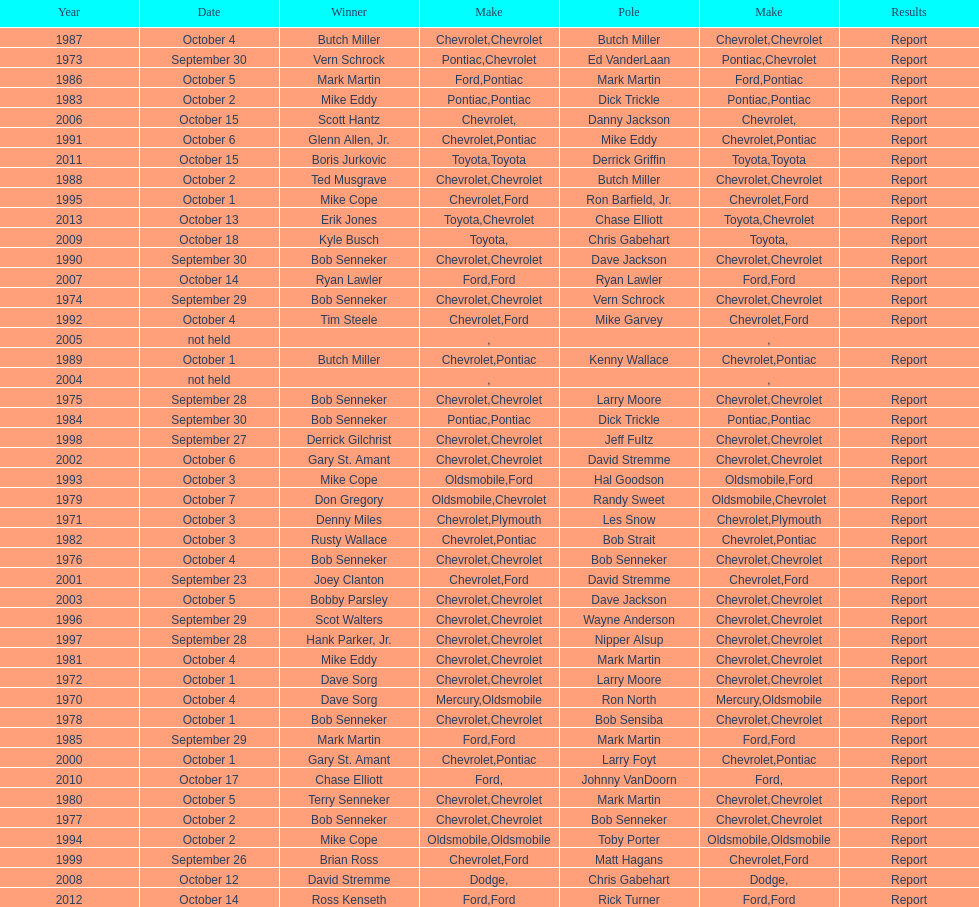Who on the list has the highest number of consecutive wins? Bob Senneker. Would you mind parsing the complete table? {'header': ['Year', 'Date', 'Winner', 'Make', 'Pole', 'Make', 'Results'], 'rows': [['1987', 'October 4', 'Butch Miller', 'Chevrolet', 'Butch Miller', 'Chevrolet', 'Report'], ['1973', 'September 30', 'Vern Schrock', 'Pontiac', 'Ed VanderLaan', 'Chevrolet', 'Report'], ['1986', 'October 5', 'Mark Martin', 'Ford', 'Mark Martin', 'Pontiac', 'Report'], ['1983', 'October 2', 'Mike Eddy', 'Pontiac', 'Dick Trickle', 'Pontiac', 'Report'], ['2006', 'October 15', 'Scott Hantz', 'Chevrolet', 'Danny Jackson', '', 'Report'], ['1991', 'October 6', 'Glenn Allen, Jr.', 'Chevrolet', 'Mike Eddy', 'Pontiac', 'Report'], ['2011', 'October 15', 'Boris Jurkovic', 'Toyota', 'Derrick Griffin', 'Toyota', 'Report'], ['1988', 'October 2', 'Ted Musgrave', 'Chevrolet', 'Butch Miller', 'Chevrolet', 'Report'], ['1995', 'October 1', 'Mike Cope', 'Chevrolet', 'Ron Barfield, Jr.', 'Ford', 'Report'], ['2013', 'October 13', 'Erik Jones', 'Toyota', 'Chase Elliott', 'Chevrolet', 'Report'], ['2009', 'October 18', 'Kyle Busch', 'Toyota', 'Chris Gabehart', '', 'Report'], ['1990', 'September 30', 'Bob Senneker', 'Chevrolet', 'Dave Jackson', 'Chevrolet', 'Report'], ['2007', 'October 14', 'Ryan Lawler', 'Ford', 'Ryan Lawler', 'Ford', 'Report'], ['1974', 'September 29', 'Bob Senneker', 'Chevrolet', 'Vern Schrock', 'Chevrolet', 'Report'], ['1992', 'October 4', 'Tim Steele', 'Chevrolet', 'Mike Garvey', 'Ford', 'Report'], ['2005', 'not held', '', '', '', '', ''], ['1989', 'October 1', 'Butch Miller', 'Chevrolet', 'Kenny Wallace', 'Pontiac', 'Report'], ['2004', 'not held', '', '', '', '', ''], ['1975', 'September 28', 'Bob Senneker', 'Chevrolet', 'Larry Moore', 'Chevrolet', 'Report'], ['1984', 'September 30', 'Bob Senneker', 'Pontiac', 'Dick Trickle', 'Pontiac', 'Report'], ['1998', 'September 27', 'Derrick Gilchrist', 'Chevrolet', 'Jeff Fultz', 'Chevrolet', 'Report'], ['2002', 'October 6', 'Gary St. Amant', 'Chevrolet', 'David Stremme', 'Chevrolet', 'Report'], ['1993', 'October 3', 'Mike Cope', 'Oldsmobile', 'Hal Goodson', 'Ford', 'Report'], ['1979', 'October 7', 'Don Gregory', 'Oldsmobile', 'Randy Sweet', 'Chevrolet', 'Report'], ['1971', 'October 3', 'Denny Miles', 'Chevrolet', 'Les Snow', 'Plymouth', 'Report'], ['1982', 'October 3', 'Rusty Wallace', 'Chevrolet', 'Bob Strait', 'Pontiac', 'Report'], ['1976', 'October 4', 'Bob Senneker', 'Chevrolet', 'Bob Senneker', 'Chevrolet', 'Report'], ['2001', 'September 23', 'Joey Clanton', 'Chevrolet', 'David Stremme', 'Ford', 'Report'], ['2003', 'October 5', 'Bobby Parsley', 'Chevrolet', 'Dave Jackson', 'Chevrolet', 'Report'], ['1996', 'September 29', 'Scot Walters', 'Chevrolet', 'Wayne Anderson', 'Chevrolet', 'Report'], ['1997', 'September 28', 'Hank Parker, Jr.', 'Chevrolet', 'Nipper Alsup', 'Chevrolet', 'Report'], ['1981', 'October 4', 'Mike Eddy', 'Chevrolet', 'Mark Martin', 'Chevrolet', 'Report'], ['1972', 'October 1', 'Dave Sorg', 'Chevrolet', 'Larry Moore', 'Chevrolet', 'Report'], ['1970', 'October 4', 'Dave Sorg', 'Mercury', 'Ron North', 'Oldsmobile', 'Report'], ['1978', 'October 1', 'Bob Senneker', 'Chevrolet', 'Bob Sensiba', 'Chevrolet', 'Report'], ['1985', 'September 29', 'Mark Martin', 'Ford', 'Mark Martin', 'Ford', 'Report'], ['2000', 'October 1', 'Gary St. Amant', 'Chevrolet', 'Larry Foyt', 'Pontiac', 'Report'], ['2010', 'October 17', 'Chase Elliott', 'Ford', 'Johnny VanDoorn', '', 'Report'], ['1980', 'October 5', 'Terry Senneker', 'Chevrolet', 'Mark Martin', 'Chevrolet', 'Report'], ['1977', 'October 2', 'Bob Senneker', 'Chevrolet', 'Bob Senneker', 'Chevrolet', 'Report'], ['1994', 'October 2', 'Mike Cope', 'Oldsmobile', 'Toby Porter', 'Oldsmobile', 'Report'], ['1999', 'September 26', 'Brian Ross', 'Chevrolet', 'Matt Hagans', 'Ford', 'Report'], ['2008', 'October 12', 'David Stremme', 'Dodge', 'Chris Gabehart', '', 'Report'], ['2012', 'October 14', 'Ross Kenseth', 'Ford', 'Rick Turner', 'Ford', 'Report']]} 